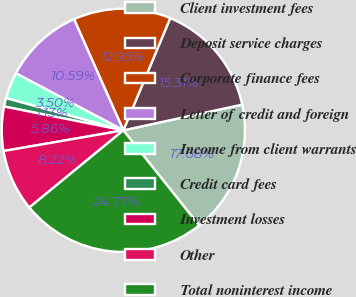Convert chart to OTSL. <chart><loc_0><loc_0><loc_500><loc_500><pie_chart><fcel>Client investment fees<fcel>Deposit service charges<fcel>Corporate finance fees<fcel>Letter of credit and foreign<fcel>Income from client warrants<fcel>Credit card fees<fcel>Investment losses<fcel>Other<fcel>Total noninterest income<nl><fcel>17.68%<fcel>15.31%<fcel>12.95%<fcel>10.59%<fcel>3.5%<fcel>1.13%<fcel>5.86%<fcel>8.22%<fcel>24.77%<nl></chart> 